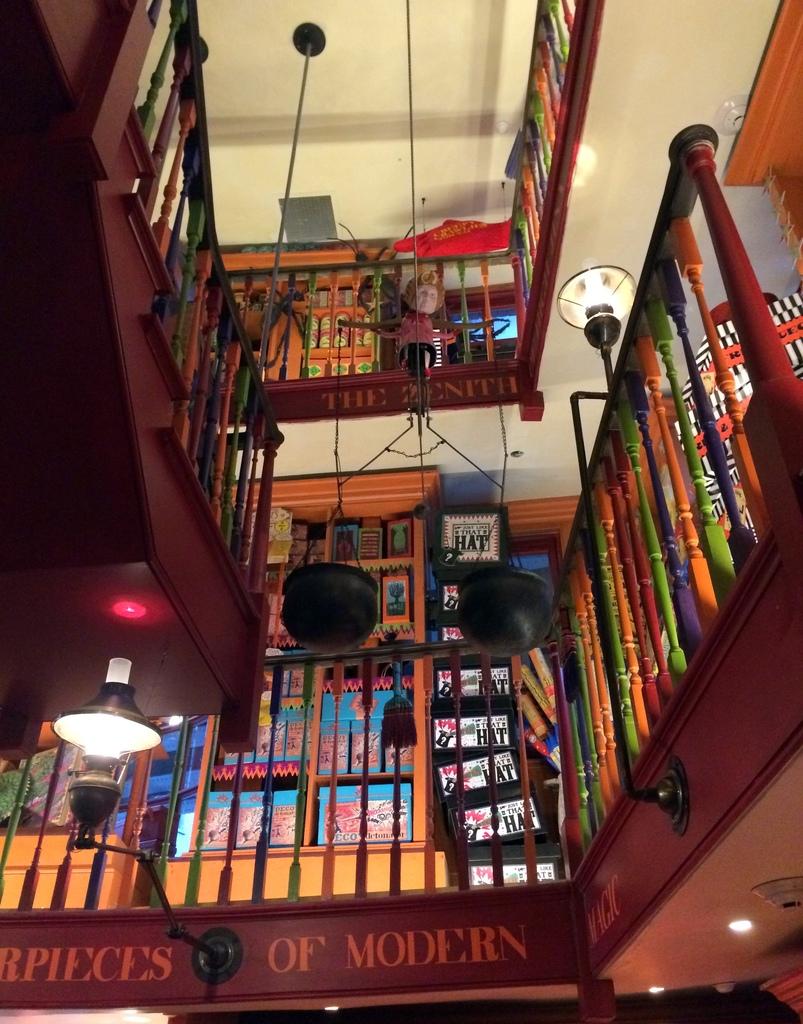Does the bottom say hairpieces of modern ?
Keep it short and to the point. Unanswerable. 